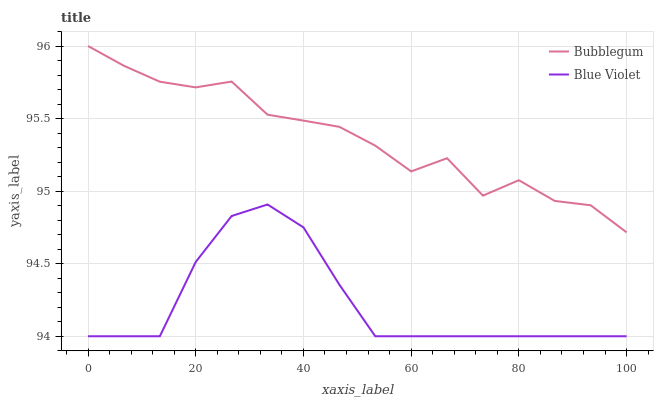Does Blue Violet have the minimum area under the curve?
Answer yes or no. Yes. Does Bubblegum have the maximum area under the curve?
Answer yes or no. Yes. Does Bubblegum have the minimum area under the curve?
Answer yes or no. No. Is Blue Violet the smoothest?
Answer yes or no. Yes. Is Bubblegum the roughest?
Answer yes or no. Yes. Is Bubblegum the smoothest?
Answer yes or no. No. Does Bubblegum have the lowest value?
Answer yes or no. No. Does Bubblegum have the highest value?
Answer yes or no. Yes. Is Blue Violet less than Bubblegum?
Answer yes or no. Yes. Is Bubblegum greater than Blue Violet?
Answer yes or no. Yes. Does Blue Violet intersect Bubblegum?
Answer yes or no. No. 